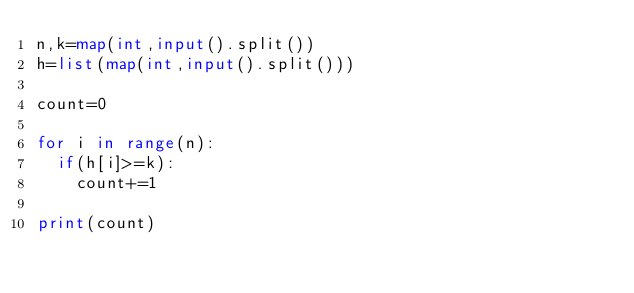Convert code to text. <code><loc_0><loc_0><loc_500><loc_500><_Python_>n,k=map(int,input().split())
h=list(map(int,input().split()))

count=0

for i in range(n):
  if(h[i]>=k):
    count+=1

print(count)
    </code> 